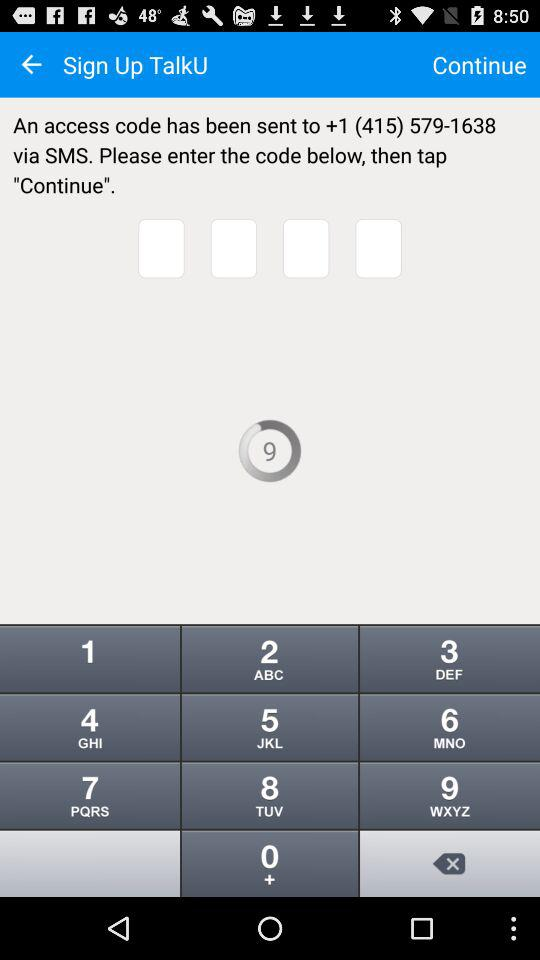How many numbers are in the access code?
Answer the question using a single word or phrase. 4 